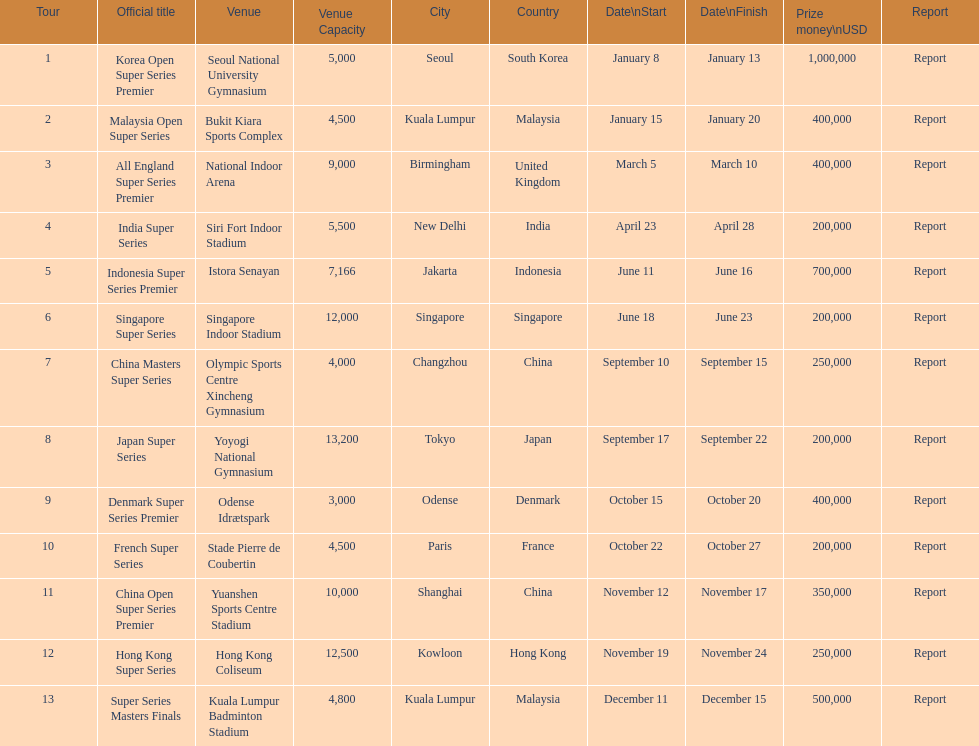Which has the same prize money as the french super series? Japan Super Series, Singapore Super Series, India Super Series. 